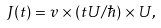Convert formula to latex. <formula><loc_0><loc_0><loc_500><loc_500>J ( t ) = v \times ( t U / \hbar { ) } \times U ,</formula> 